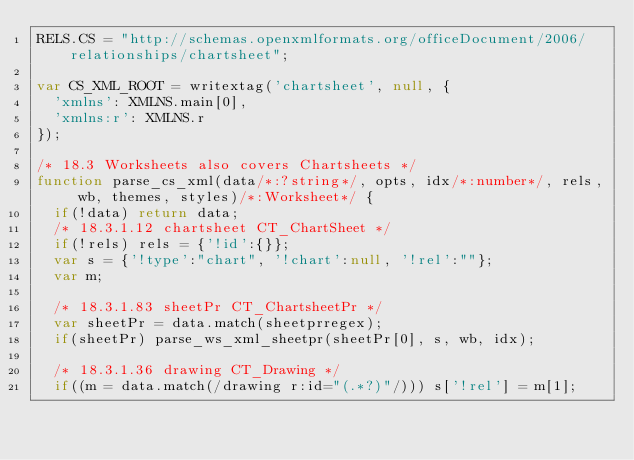Convert code to text. <code><loc_0><loc_0><loc_500><loc_500><_JavaScript_>RELS.CS = "http://schemas.openxmlformats.org/officeDocument/2006/relationships/chartsheet";

var CS_XML_ROOT = writextag('chartsheet', null, {
	'xmlns': XMLNS.main[0],
	'xmlns:r': XMLNS.r
});

/* 18.3 Worksheets also covers Chartsheets */
function parse_cs_xml(data/*:?string*/, opts, idx/*:number*/, rels, wb, themes, styles)/*:Worksheet*/ {
	if(!data) return data;
	/* 18.3.1.12 chartsheet CT_ChartSheet */
	if(!rels) rels = {'!id':{}};
	var s = {'!type':"chart", '!chart':null, '!rel':""};
	var m;

	/* 18.3.1.83 sheetPr CT_ChartsheetPr */
	var sheetPr = data.match(sheetprregex);
	if(sheetPr) parse_ws_xml_sheetpr(sheetPr[0], s, wb, idx);

	/* 18.3.1.36 drawing CT_Drawing */
	if((m = data.match(/drawing r:id="(.*?)"/))) s['!rel'] = m[1];
</code> 